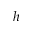<formula> <loc_0><loc_0><loc_500><loc_500>h</formula> 